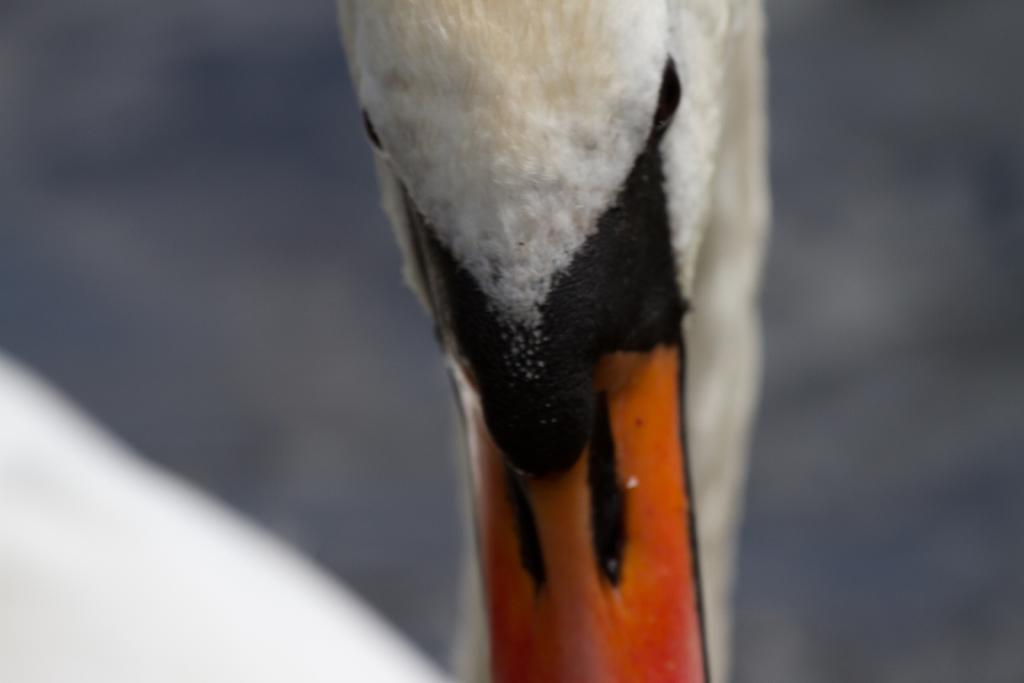What type of animal is in the image? There is a bird in the image. Can you describe the background of the image? The background of the image is blurred. What type of can is visible in the image? There is no can present in the image; it only features a bird and a blurred background. How many houses can be seen in the image? There are no houses visible in the image; it only features a bird and a blurred background. 